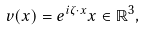Convert formula to latex. <formula><loc_0><loc_0><loc_500><loc_500>v ( x ) = e ^ { i \zeta \cdot x } x \in \mathbb { R } ^ { 3 } ,</formula> 